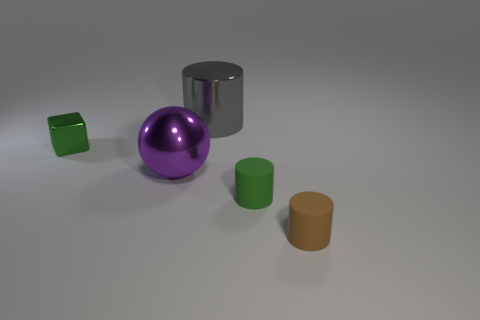Add 3 green rubber cubes. How many objects exist? 8 Subtract all cubes. How many objects are left? 4 Add 2 purple balls. How many purple balls exist? 3 Subtract 0 brown cubes. How many objects are left? 5 Subtract all brown rubber spheres. Subtract all tiny brown cylinders. How many objects are left? 4 Add 1 purple objects. How many purple objects are left? 2 